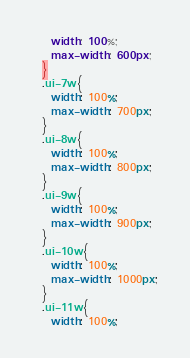Convert code to text. <code><loc_0><loc_0><loc_500><loc_500><_CSS_>    width: 100%;
    max-width: 600px;
  }
  .ui-7w{
    width: 100%;
    max-width: 700px;
  }
  .ui-8w{
    width: 100%;
    max-width: 800px;
  }
  .ui-9w{
    width: 100%;
    max-width: 900px;
  }
  .ui-10w{
    width: 100%;
    max-width: 1000px;
  }
  .ui-11w{
    width: 100%;</code> 